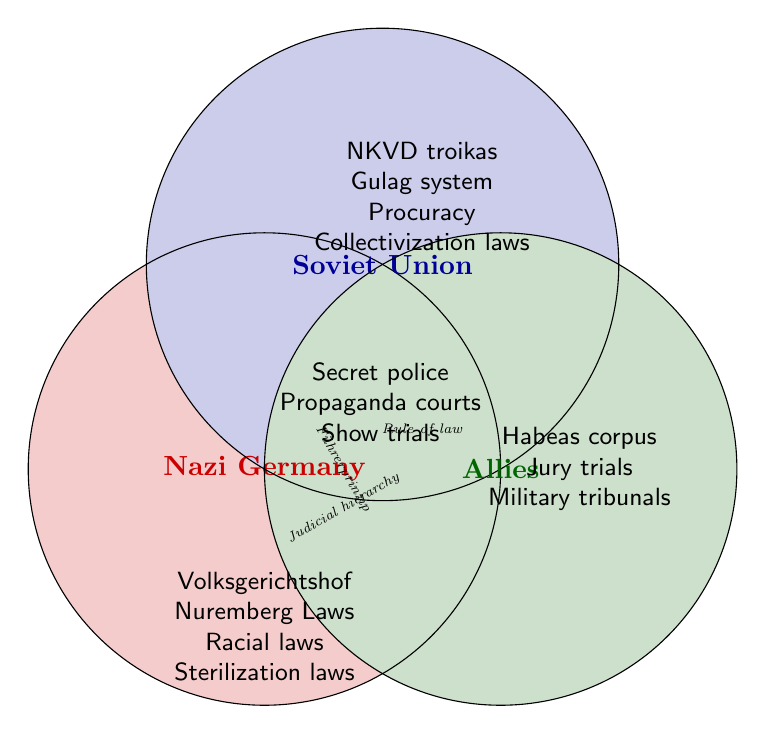Who used Volksgerichtshof? Volksgerichtshof is listed under the Nazi Germany section.
Answer: Nazi Germany Which legal system includes Habeas corpus? Habeas corpus is found in the Allies section.
Answer: Allies What do Nazi Germany and the Soviet Union have in common? Both share Secret police and Propaganda courts.
Answer: Secret police, Propaganda courts Name a unique legal system practice from the Soviet Union. NKVD troikas, Gulag system, Procuracy, and Collectivization laws are unique to the Soviet Union.
Answer: NKVD troikas, Gulag system, Procuracy, Collectivization laws What legal principles are shared by all groups? Rule of law and Judicial hierarchy are shared by all.
Answer: Rule of law, Judicial hierarchy Which legal acts specifically targeted racial groups? Racial laws and Nuremberg Laws are under Nazi Germany, indicating they targeted racial groups.
Answer: Racial laws, Nuremberg Laws How do the Allies' legal systems differ from those of Nazi Germany and the Soviet Union? The Allies include Habeas corpus, Jury trials, and Military tribunals, which are not found in Nazi Germany or the Soviet Union.
Answer: Habeas corpus, Jury trials, Military tribunals What does the Soviet Union's legal system include that is not shared with Nazi Germany or Allies? NKVD troikas, Gulag system, Procuracy, and Collectivization laws are exclusively in the Soviet Union's section.
Answer: NKVD troikas, Gulag system, Procuracy, Collectivization laws 